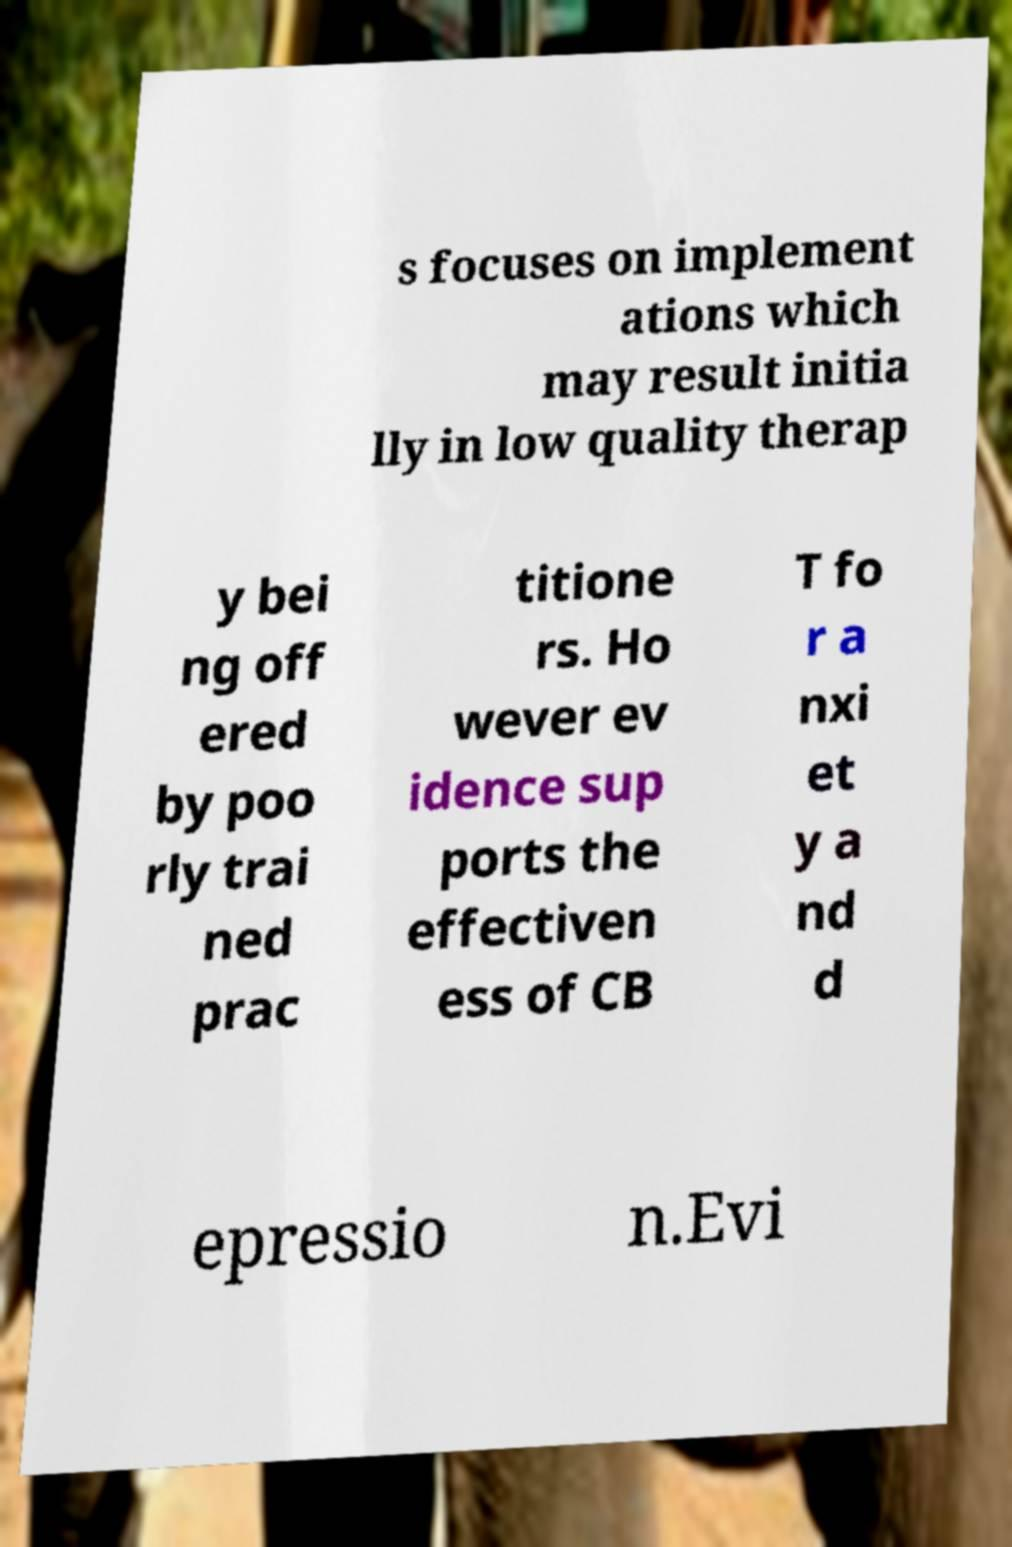For documentation purposes, I need the text within this image transcribed. Could you provide that? s focuses on implement ations which may result initia lly in low quality therap y bei ng off ered by poo rly trai ned prac titione rs. Ho wever ev idence sup ports the effectiven ess of CB T fo r a nxi et y a nd d epressio n.Evi 